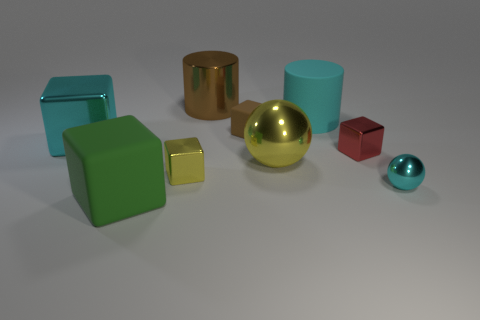Subtract all cyan blocks. How many blocks are left? 4 Subtract 1 blocks. How many blocks are left? 4 Subtract all cyan balls. How many balls are left? 1 Add 8 large green rubber cubes. How many large green rubber cubes are left? 9 Add 1 tiny red shiny things. How many tiny red shiny things exist? 2 Subtract 0 green cylinders. How many objects are left? 9 Subtract all spheres. How many objects are left? 7 Subtract all red balls. Subtract all purple cylinders. How many balls are left? 2 Subtract all red blocks. How many purple spheres are left? 0 Subtract all brown shiny cubes. Subtract all tiny brown rubber blocks. How many objects are left? 8 